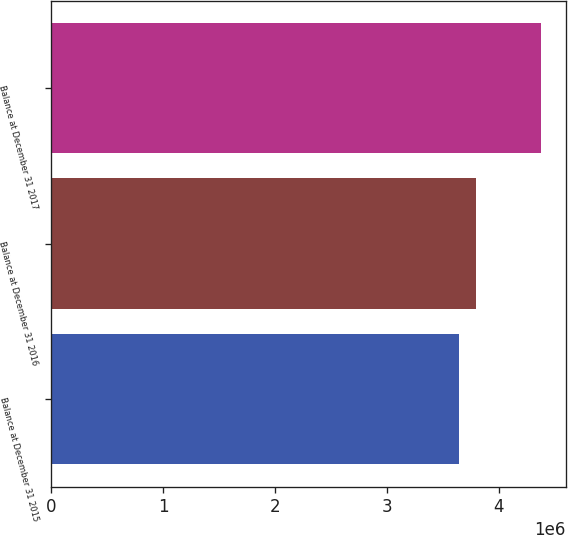<chart> <loc_0><loc_0><loc_500><loc_500><bar_chart><fcel>Balance at December 31 2015<fcel>Balance at December 31 2016<fcel>Balance at December 31 2017<nl><fcel>3.64458e+06<fcel>3.79975e+06<fcel>4.38318e+06<nl></chart> 